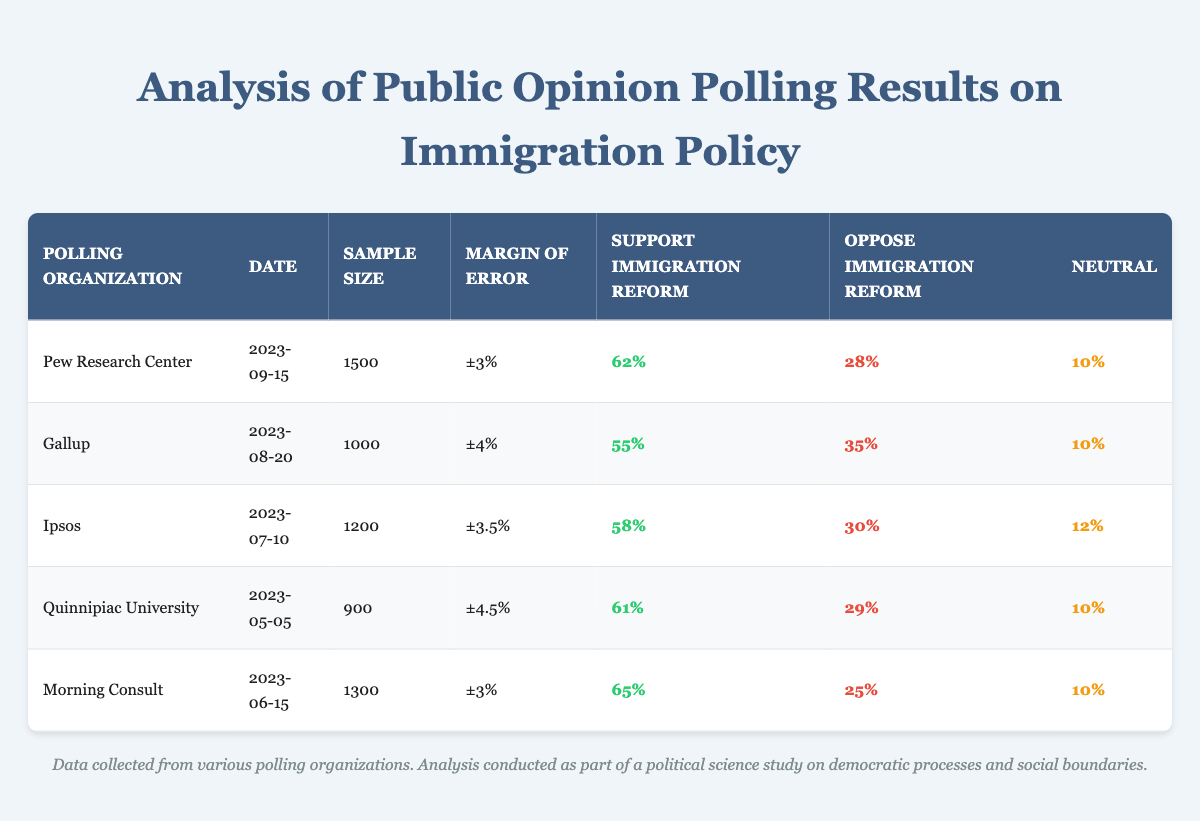What percentage of respondents supported immigration reform according to the Pew Research Center? The table lists the response of the Pew Research Center under the "Support Immigration Reform" column. According to that entry, 62% of respondents supported immigration reform.
Answer: 62% What is the margin of error for the Gallup poll conducted on August 20, 2023? The margin of error for the Gallup poll is displayed in the corresponding column for that entry. It shows a margin of error of ±4%.
Answer: ±4% Which polling organization had the lowest percentage of support for immigration reform? To determine the lowest support, we can look at the "Support Immigration Reform" column. The lowest percentage is from Gallup with 55%.
Answer: Gallup Calculate the average percentage of support for immigration reform across all polling organizations listed. The support percentages are 62, 55, 58, 61, and 65. Summing these gives 62 + 55 + 58 + 61 + 65 = 301. There are 5 organizations, so the average is 301/5 = 60.2%.
Answer: 60.2% Is it true that more than half of the respondents opposed immigration reform according to the Ipsos poll? The Ipsos poll shows that 30% of respondents opposed immigration reform. Since 30% is less than 50%, the statement is false.
Answer: No What is the difference in support for immigration reform between Morning Consult and Quinnipiac University? Morning Consult's support is 65% and Quinnipiac University's is 61%. The difference is calculated as 65 - 61 = 4%.
Answer: 4% Which poll had the largest sample size and what was the percentage of support for immigration reform? The largest sample size is from Pew Research Center with 1500 respondents, corresponding to a support percentage of 62%.
Answer: Pew Research Center, 62% Is it true that all polling organizations reported a neutral response percentage of 10%? The table indicates that most organizations reported 10% neutral responses, but Ipsos reported 12%. Thus, not all polling organizations have a neutral response percentage of 10%.
Answer: No What is the total sample size of all the polls combined? The sample sizes listed are 1500, 1000, 1200, 900, and 1300. Adding these gives 1500 + 1000 + 1200 + 900 + 1300 = 4900.
Answer: 4900 